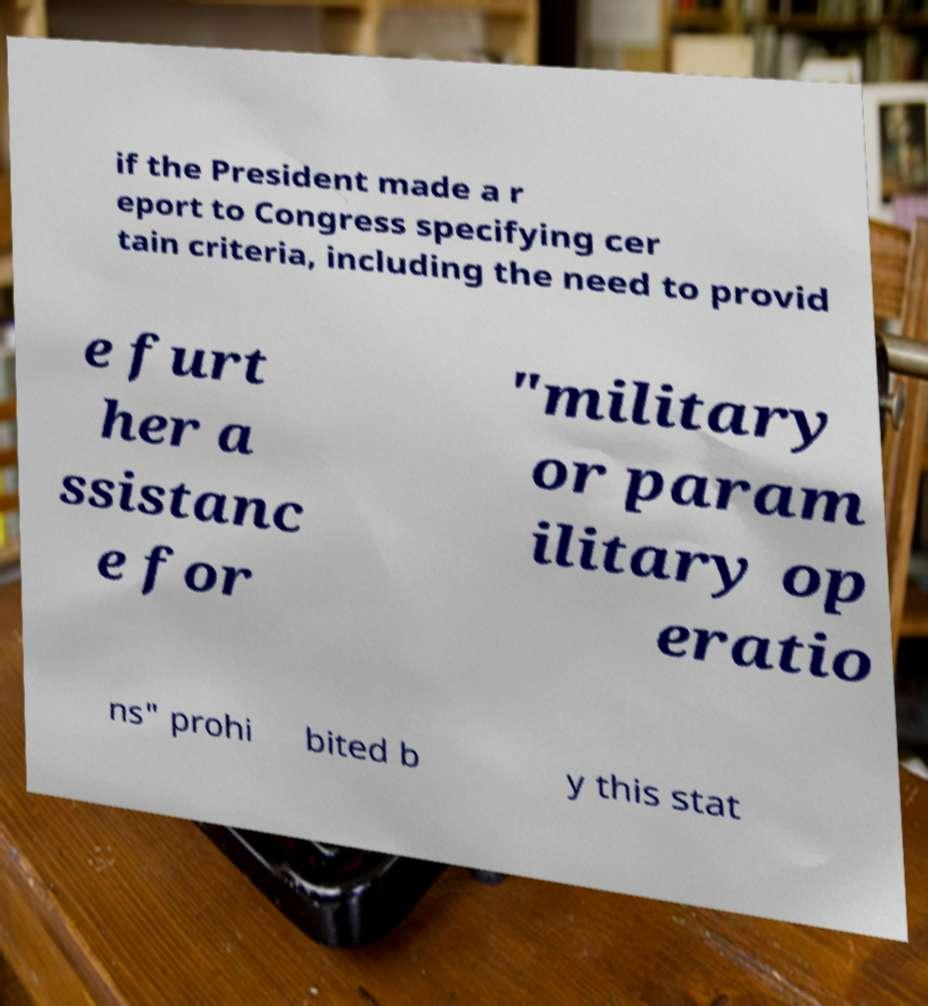Can you accurately transcribe the text from the provided image for me? if the President made a r eport to Congress specifying cer tain criteria, including the need to provid e furt her a ssistanc e for "military or param ilitary op eratio ns" prohi bited b y this stat 